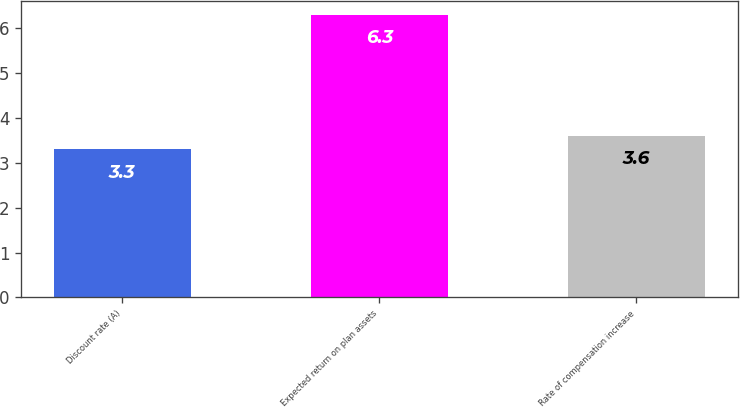<chart> <loc_0><loc_0><loc_500><loc_500><bar_chart><fcel>Discount rate (A)<fcel>Expected return on plan assets<fcel>Rate of compensation increase<nl><fcel>3.3<fcel>6.3<fcel>3.6<nl></chart> 